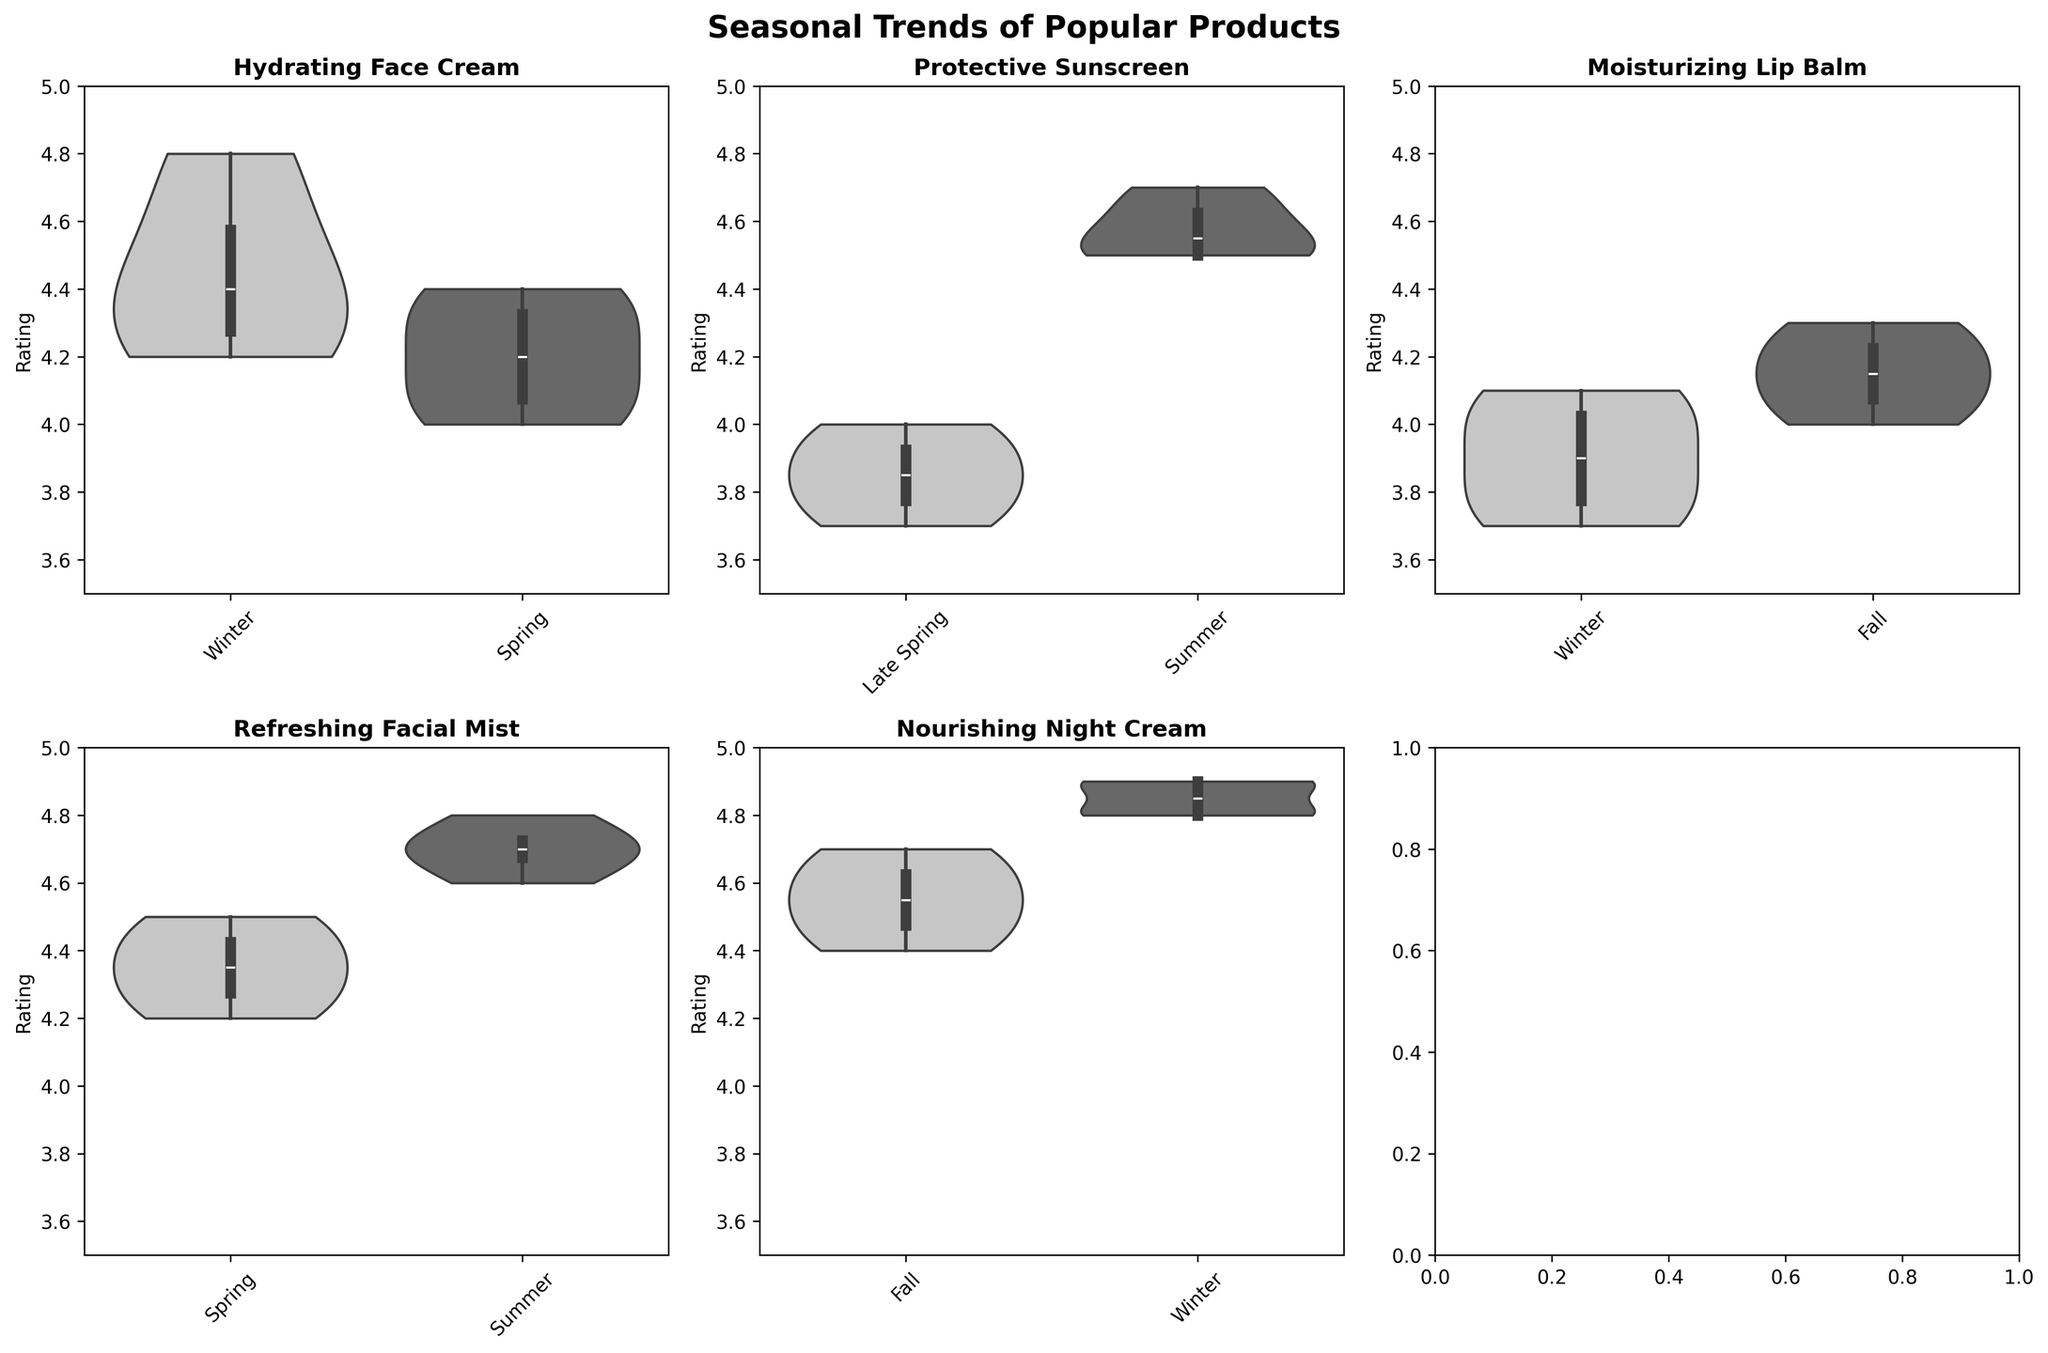How many products are compared in the figure? There are six subplots in the figure, and each subplot represents a different product.
Answer: Six Which product has the highest median rating in Winter? By examining the subplots, we see that the "Nourishing Night Cream" in Winter has the highest median rating, as its median line is closest to the top of the y-axis compared to other products in Winter.
Answer: Nourishing Night Cream How does the median rating of "Hydrating Face Cream" in Winter compare to Spring? The median line for "Hydrating Face Cream" in Winter is higher than in Spring, indicating that the winter ratings are generally higher.
Answer: Higher in Winter Are there any products that have a higher range of ratings in one season compared to another? "Protective Sunscreen" in Late Spring has a lower range of ratings compared to Summer, as seen by the wider spread of the violin plot in Summer.
Answer: Protective Sunscreen What is the season with the highest ratings for "Refreshing Facial Mist"? The subplot for "Refreshing Facial Mist" shows the highest ratings in Summer, as the median line and the overall distribution are higher.
Answer: Summer Which product shows less variability in ratings during Fall? The "Nourishing Night Cream" in Fall shows less variability with a narrow distribution, indicating consistent high ratings.
Answer: Nourishing Night Cream Which season has the overall lowest ratings for any product? "Protective Sunscreen" during Late Spring shows the lowest ratings with the median and range being lower than other products and seasons.
Answer: Late Spring for Protective Sunscreen Which product shows a consistent increase in ratings from one season to the next? "Refreshing Facial Mist" shows increasing ratings from Spring to Summer, as noted by both the median and the spread of the violin plot moving upwards.
Answer: Refreshing Facial Mist Is there a product where ratings remain relatively stable regardless of the season? "Moisturizing Lip Balm" has relatively stable ratings across Winter and Fall with minimal changes in the median and overall distribution.
Answer: Moisturizing Lip Balm Which season is most favorable for "Protective Sunscreen"? The highest median and tightest clustering of ratings for "Protective Sunscreen" occur in Summer, making it the most favorable season.
Answer: Summer 